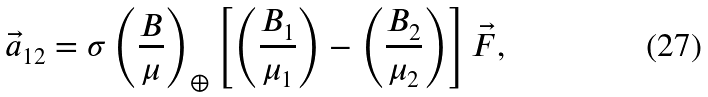<formula> <loc_0><loc_0><loc_500><loc_500>\vec { a } _ { 1 2 } = \sigma \left ( \frac { B } { \mu } \right ) _ { \oplus } \left [ \left ( \frac { B _ { 1 } } { \mu _ { 1 } } \right ) - \left ( \frac { B _ { 2 } } { \mu _ { 2 } } \right ) \right ] \vec { F } ,</formula> 